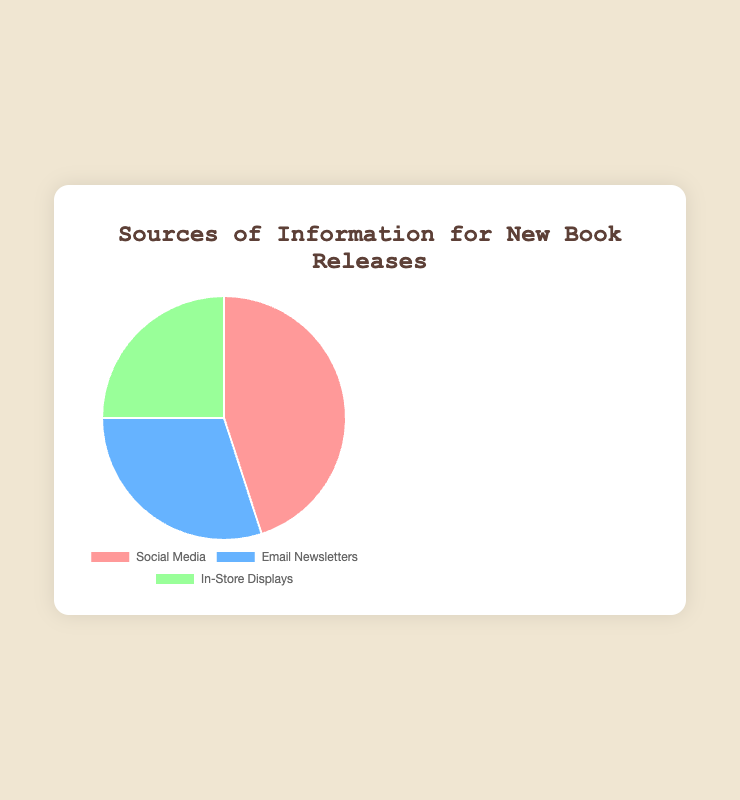What is the most common source of information for new book releases? From the pie chart, the segment corresponding to Social Media is the largest, indicating it has the highest percentage at 45%.
Answer: Social Media What is the combined percentage of Social Media and Email Newsletters? The percentage for Social Media is 45% and for Email Newsletters is 30%. Adding these together, 45% + 30% = 75%.
Answer: 75% Which source of information has the smallest percentage? The smallest segment in the pie chart is for In-Store Displays, which has a percentage of 25%.
Answer: In-Store Displays How much larger is the Social Media segment compared to the In-Store Displays segment? The percentage for Social Media is 45% and for In-Store Displays is 25%. The difference is 45% - 25% = 20%.
Answer: 20% What is the average percentage for all three sources of information? The percentages are 45% for Social Media, 30% for Email Newsletters, and 25% for In-Store Displays. The average is (45% + 30% + 25%) / 3 = 100% / 3 = 33.33%.
Answer: 33.33% Which two sources combined constitute less than half of the total sources? The percentages for Email Newsletters and In-Store Displays are 30% and 25%, respectively. Summing these, 30% + 25% = 55%, which is more than half. Thus, the other combinations involving Social Media will also exceed 50%. Hence, no two sources combined constitute less than half.
Answer: None How does the segment color help visualize the percentage of each source? Each section of the pie chart is color-coded, with Social Media in red, Email Newsletters in blue, and In-Store Displays in green. The visual size and distinct colors make it easy to compare the relative sizes of the segments.
Answer: Color aids comparison What percentage difference is there between the largest and smallest segments? The largest segment is Social Media at 45% and the smallest is In-Store Displays at 25%. The difference is 45% - 25% = 20%.
Answer: 20% What is the total percentage represented by all sources on the chart? Adding the percentages of Social Media (45%), Email Newsletters (30%), and In-Store Displays (25%) gives 45% + 30% + 25% = 100%.
Answer: 100% Which source is represented by the blue color in the pie chart? From the color legend in the chart, Email Newsletters are represented by the blue color.
Answer: Email Newsletters 